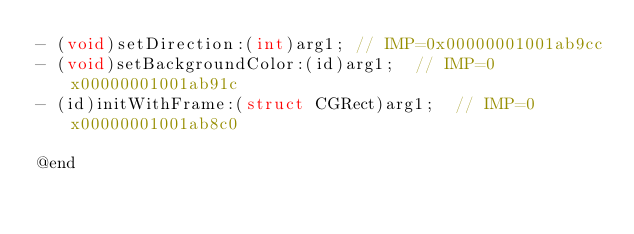Convert code to text. <code><loc_0><loc_0><loc_500><loc_500><_C_>- (void)setDirection:(int)arg1;	// IMP=0x00000001001ab9cc
- (void)setBackgroundColor:(id)arg1;	// IMP=0x00000001001ab91c
- (id)initWithFrame:(struct CGRect)arg1;	// IMP=0x00000001001ab8c0

@end

</code> 